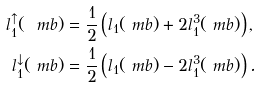Convert formula to latex. <formula><loc_0><loc_0><loc_500><loc_500>l _ { 1 } ^ { \uparrow } ( \ m b ) & = \frac { 1 } { 2 } \left ( l _ { 1 } ( \ m b ) + 2 l _ { 1 } ^ { 3 } ( \ m b ) \right ) , \\ l _ { 1 } ^ { \downarrow } ( \ m b ) & = \frac { 1 } { 2 } \left ( l _ { 1 } ( \ m b ) - 2 l _ { 1 } ^ { 3 } ( \ m b ) \right ) .</formula> 